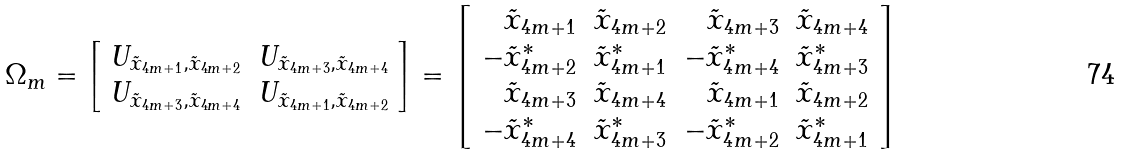Convert formula to latex. <formula><loc_0><loc_0><loc_500><loc_500>\Omega _ { m } = \left [ \begin{array} { r r } U _ { \tilde { x } _ { 4 m + 1 } , \tilde { x } _ { 4 m + 2 } } & U _ { \tilde { x } _ { 4 m + 3 } , \tilde { x } _ { 4 m + 4 } } \\ U _ { \tilde { x } _ { 4 m + 3 } , \tilde { x } _ { 4 m + 4 } } & U _ { \tilde { x } _ { 4 m + 1 } , \tilde { x } _ { 4 m + 2 } } \\ \end{array} \right ] = \left [ \begin{array} { r r r r } \tilde { x } _ { 4 m + 1 } & \tilde { x } _ { 4 m + 2 } & \tilde { x } _ { 4 m + 3 } & \tilde { x } _ { 4 m + 4 } \\ - \tilde { x } _ { 4 m + 2 } ^ { * } & \tilde { x } _ { 4 m + 1 } ^ { * } & - \tilde { x } _ { 4 m + 4 } ^ { * } & \tilde { x } _ { 4 m + 3 } ^ { * } \\ \tilde { x } _ { 4 m + 3 } & \tilde { x } _ { 4 m + 4 } & \tilde { x } _ { 4 m + 1 } & \tilde { x } _ { 4 m + 2 } \\ - \tilde { x } _ { 4 m + 4 } ^ { * } & \tilde { x } _ { 4 m + 3 } ^ { * } & - \tilde { x } _ { 4 m + 2 } ^ { * } & \tilde { x } _ { 4 m + 1 } ^ { * } \\ \end{array} \right ]</formula> 